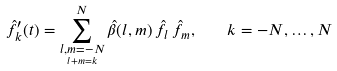<formula> <loc_0><loc_0><loc_500><loc_500>\hat { f } _ { k } ^ { \prime } ( t ) = \sum _ { \underset { l + m = k } { l , m = - N } } ^ { N } \hat { \beta } ( l , m ) \, \hat { f } _ { l } \, \hat { f } _ { m } , \quad k = - N , \dots , N</formula> 